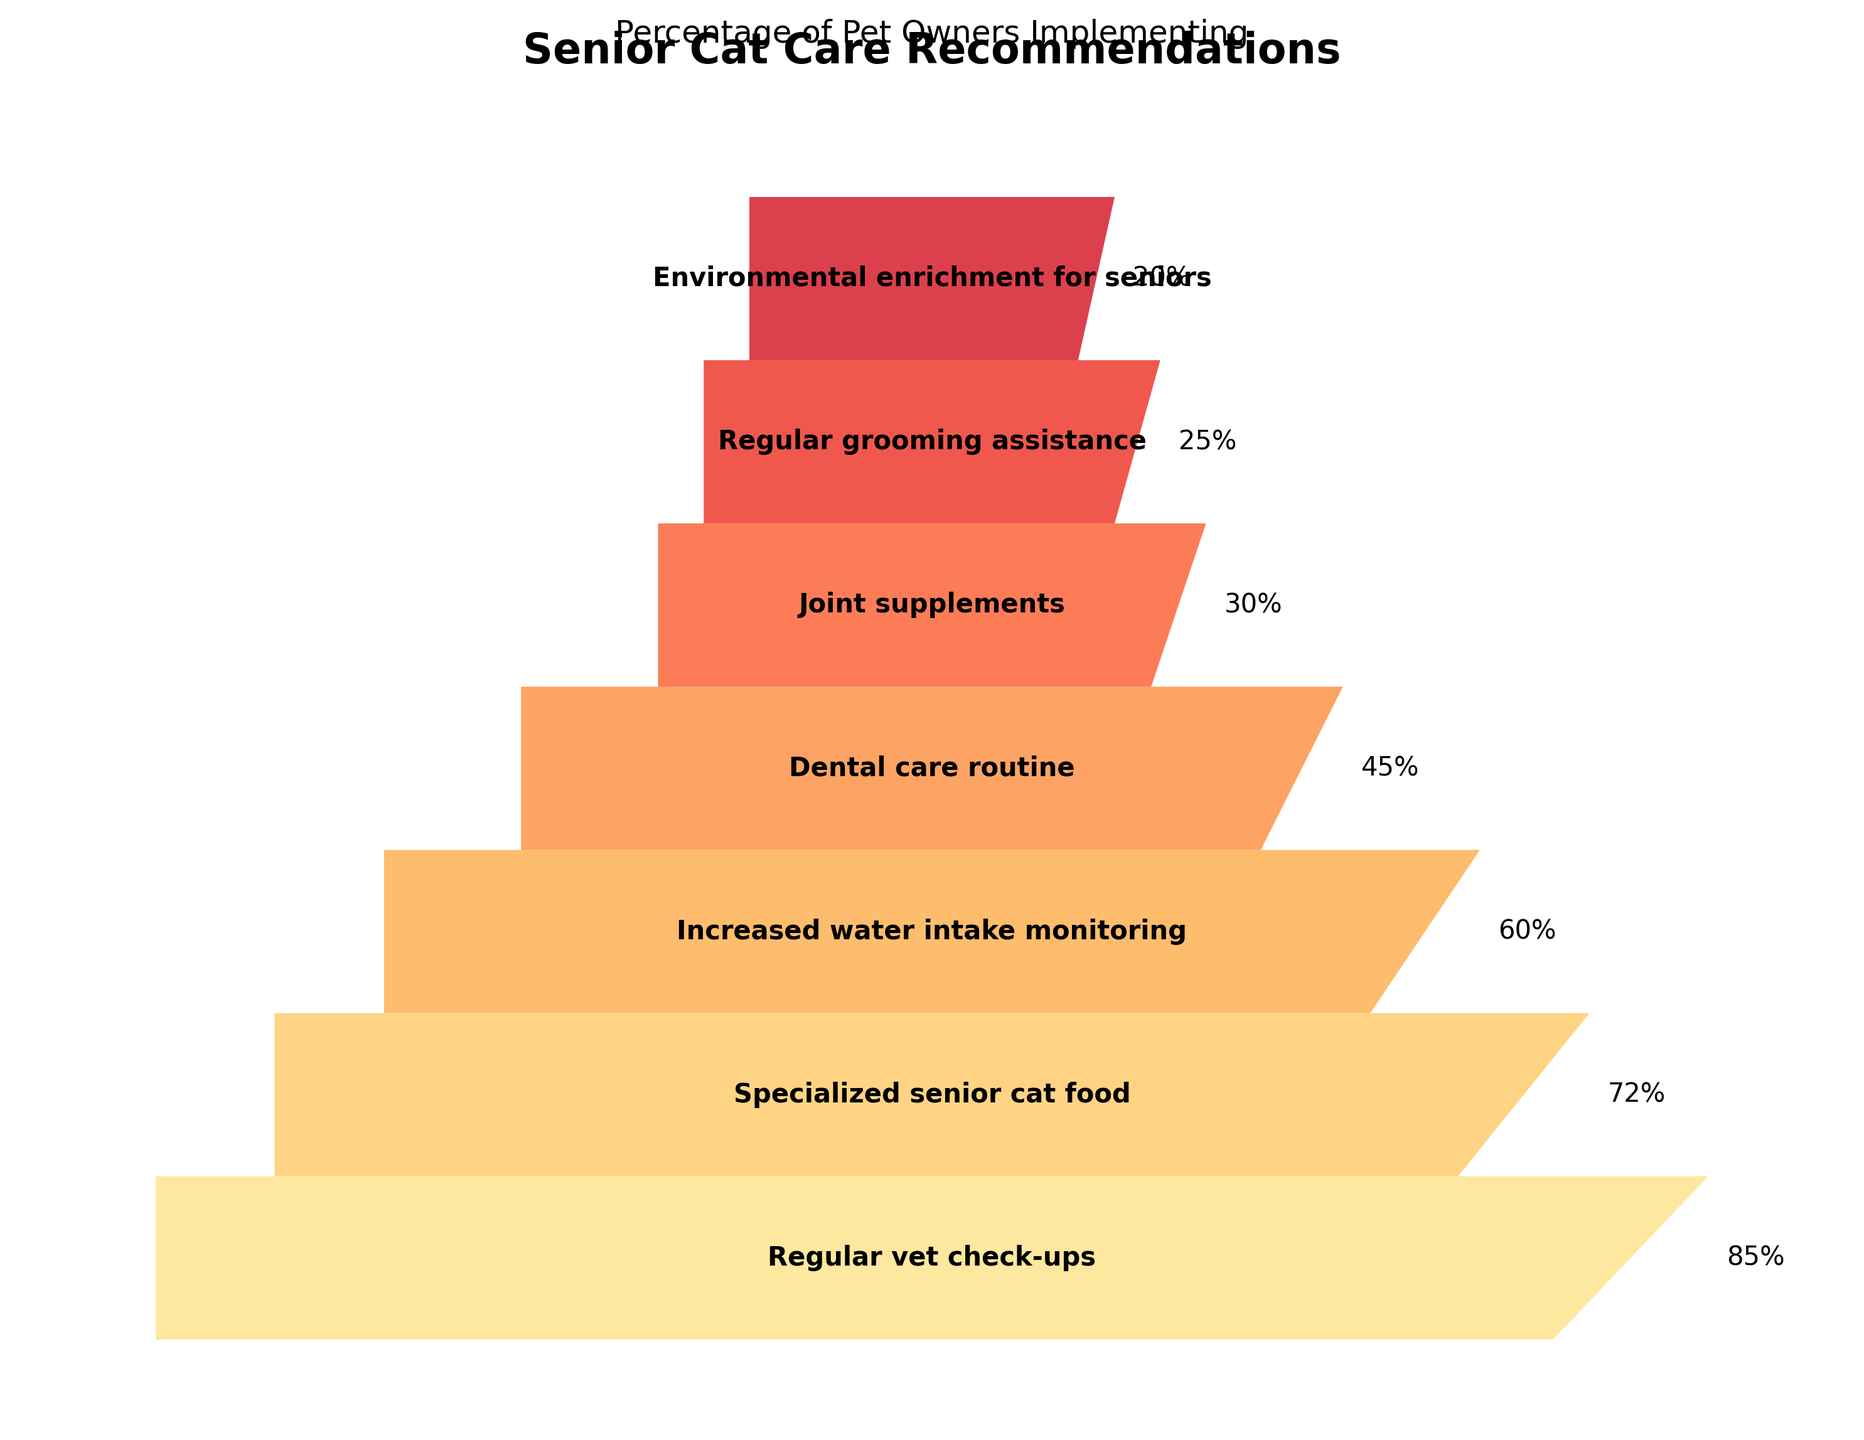What's the highest percentage of pet owners implementing a recommendation? The highest percentage can be identified by looking at the top segment of the funnel chart, which represents "Regular vet check-ups" and shows an associated percentage.
Answer: 85% What's the title of the chart? The title is written at the top of the figure in a larger, bold font.
Answer: Senior Cat Care Recommendations Which recommendation has the lowest percentage of implementation? The lowest percentage is at the bottom of the funnel chart, referring to the "Environmental enrichment for seniors" segment.
Answer: Environmental enrichment for seniors How many percentage points fewer implement regular grooming assistance compared to dental care routine? The percentage for dental care routine is 45%, and for regular grooming assistance, it is 25%. The difference is calculated as 45% - 25%.
Answer: 20% What is the difference in implementation between specialized senior cat food and increased water intake monitoring? The chart shows 72% for specialized senior cat food and 60% for increased water intake monitoring. Subtracting these gives the difference.
Answer: 12% Which recommendation related to health monitoring has a higher percentage of implementation: increased water intake or joint supplements? By comparing the two segments, "Increased water intake monitoring" shows 60%, while "Joint supplements" shows 30%.
Answer: Increased water intake monitoring What percentage of pet owners implement dental care routines? This percentage can be read directly from the chart next to the "Dental care routine" segment.
Answer: 45% Are there more pet owners implementing joint supplements or regular grooming assistance? Comparing the two segments, "Joint supplements" show 30%, while "Regular grooming assistance" shows 25%.
Answer: Joint supplements What is the average percentage of implementation for the recommendations listed? Summing all listed percentages (85 + 72 + 60 + 45 + 30 + 25 + 20) and dividing by the number of recommendations (7) gives the average.
Answer: 48.14 Which recommendation has a percentage of implementation between 70% and 80%? "Specialized senior cat food" is the recommendation with a percentage of 72%, fitting within that range.
Answer: Specialized senior cat food 